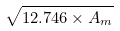Convert formula to latex. <formula><loc_0><loc_0><loc_500><loc_500>\sqrt { 1 2 . 7 4 6 \times A _ { m } }</formula> 